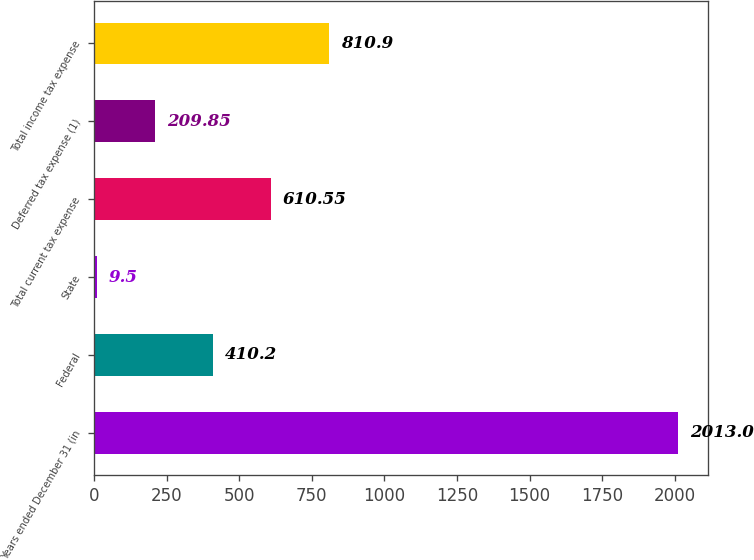<chart> <loc_0><loc_0><loc_500><loc_500><bar_chart><fcel>Years ended December 31 (in<fcel>Federal<fcel>State<fcel>Total current tax expense<fcel>Deferred tax expense (1)<fcel>Total income tax expense<nl><fcel>2013<fcel>410.2<fcel>9.5<fcel>610.55<fcel>209.85<fcel>810.9<nl></chart> 